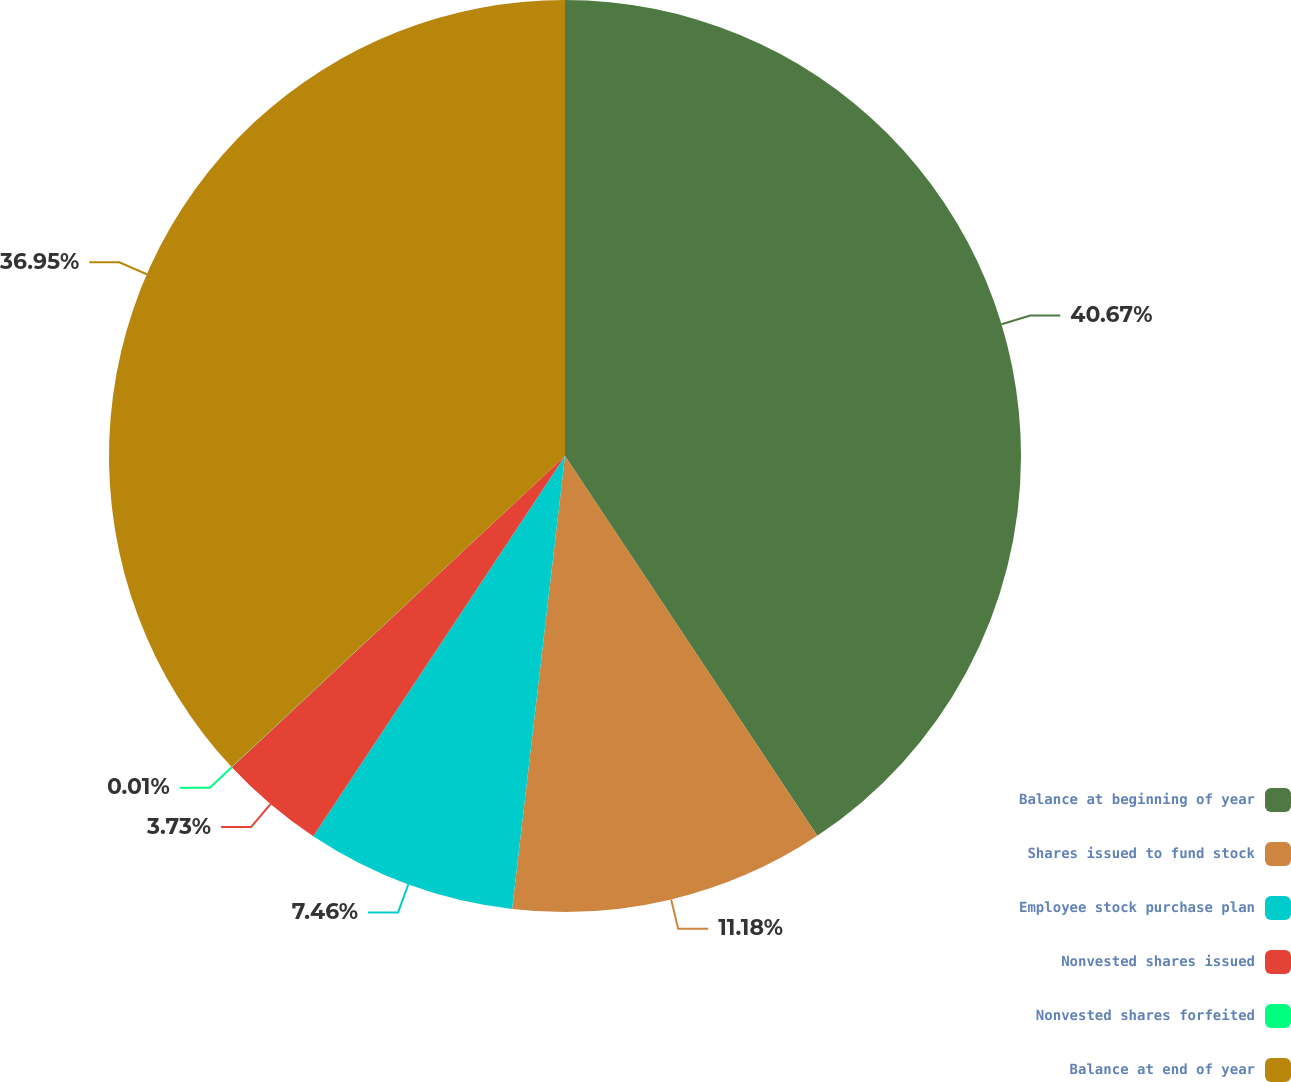Convert chart. <chart><loc_0><loc_0><loc_500><loc_500><pie_chart><fcel>Balance at beginning of year<fcel>Shares issued to fund stock<fcel>Employee stock purchase plan<fcel>Nonvested shares issued<fcel>Nonvested shares forfeited<fcel>Balance at end of year<nl><fcel>40.67%<fcel>11.18%<fcel>7.46%<fcel>3.73%<fcel>0.01%<fcel>36.95%<nl></chart> 